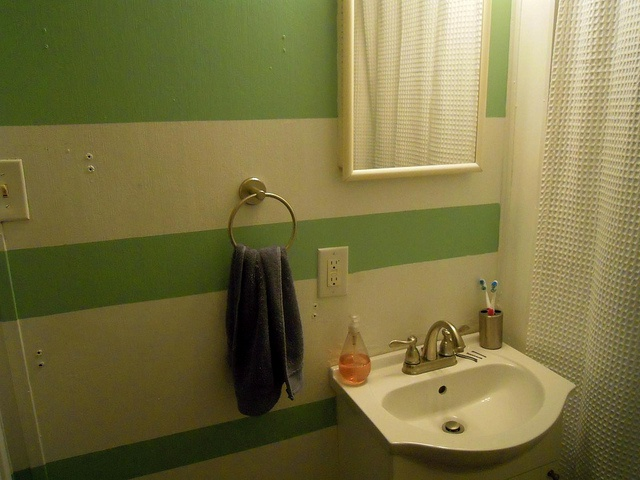Describe the objects in this image and their specific colors. I can see sink in darkgreen, tan, and olive tones, bottle in darkgreen, brown, and olive tones, toothbrush in darkgreen, olive, gray, and maroon tones, and toothbrush in darkgreen, tan, gray, and black tones in this image. 